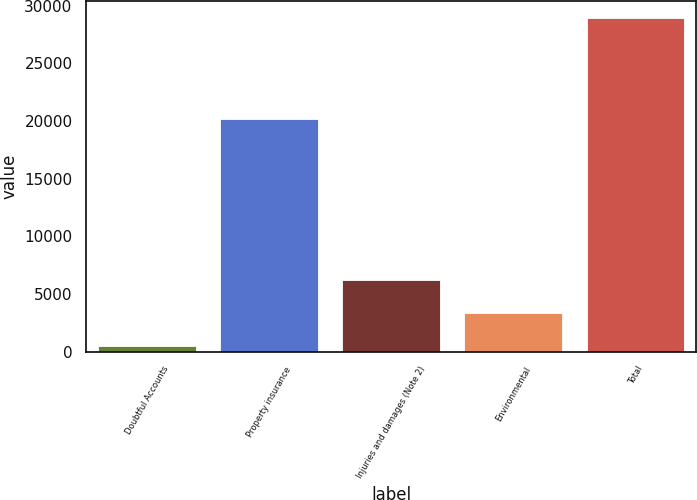<chart> <loc_0><loc_0><loc_500><loc_500><bar_chart><fcel>Doubtful Accounts<fcel>Property insurance<fcel>Injuries and damages (Note 2)<fcel>Environmental<fcel>Total<nl><fcel>473<fcel>20146<fcel>6188<fcel>3318<fcel>28923<nl></chart> 